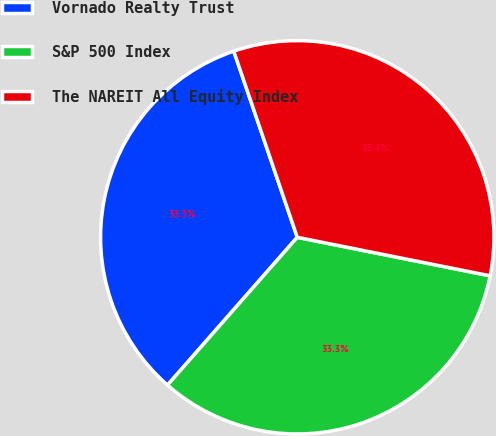<chart> <loc_0><loc_0><loc_500><loc_500><pie_chart><fcel>Vornado Realty Trust<fcel>S&P 500 Index<fcel>The NAREIT All Equity Index<nl><fcel>33.3%<fcel>33.33%<fcel>33.37%<nl></chart> 